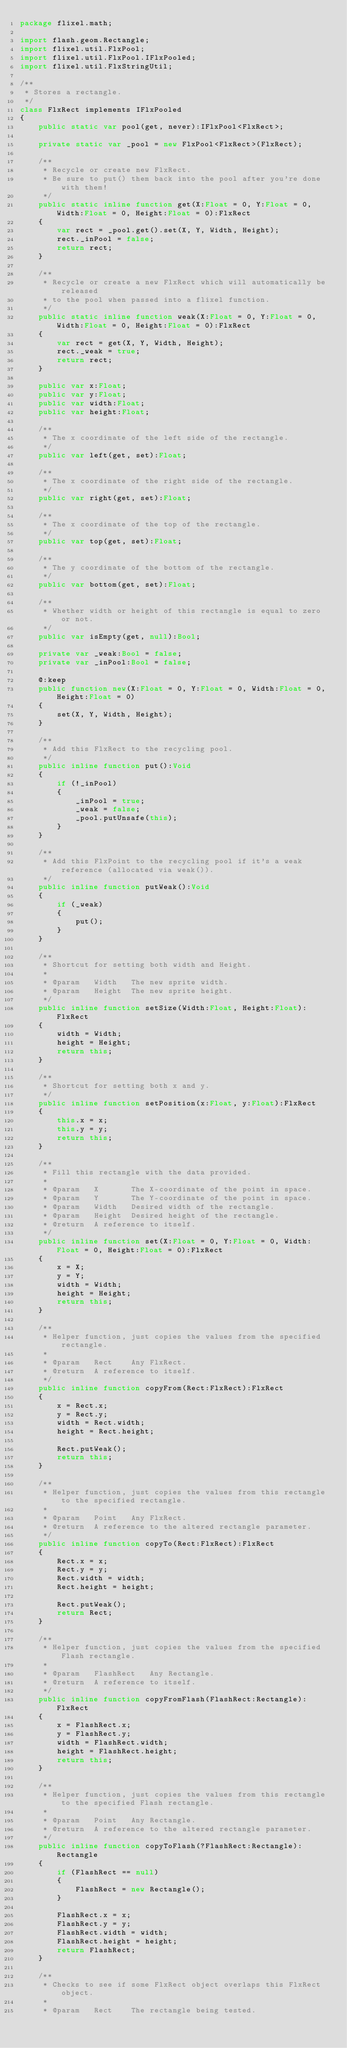<code> <loc_0><loc_0><loc_500><loc_500><_Haxe_>package flixel.math;

import flash.geom.Rectangle;
import flixel.util.FlxPool;
import flixel.util.FlxPool.IFlxPooled;
import flixel.util.FlxStringUtil;

/**
 * Stores a rectangle.
 */
class FlxRect implements IFlxPooled
{
	public static var pool(get, never):IFlxPool<FlxRect>;
	
	private static var _pool = new FlxPool<FlxRect>(FlxRect);
	
	/**
	 * Recycle or create new FlxRect.
	 * Be sure to put() them back into the pool after you're done with them!
	 */
	public static inline function get(X:Float = 0, Y:Float = 0, Width:Float = 0, Height:Float = 0):FlxRect
	{
		var rect = _pool.get().set(X, Y, Width, Height);
		rect._inPool = false;
		return rect;
	}
	
	/**
	 * Recycle or create a new FlxRect which will automatically be released 
	 * to the pool when passed into a flixel function.
	 */
	public static inline function weak(X:Float = 0, Y:Float = 0, Width:Float = 0, Height:Float = 0):FlxRect
	{
		var rect = get(X, Y, Width, Height);
		rect._weak = true;
		return rect;
	}
	
	public var x:Float;
	public var y:Float;
	public var width:Float;
	public var height:Float;
	
	/**
	 * The x coordinate of the left side of the rectangle.
	 */
	public var left(get, set):Float;
	
	/**
	 * The x coordinate of the right side of the rectangle.
	 */
	public var right(get, set):Float;
	
	/**
	 * The x coordinate of the top of the rectangle.
	 */
	public var top(get, set):Float;
	
	/**
	 * The y coordinate of the bottom of the rectangle.
	 */
	public var bottom(get, set):Float;
	
	/**
	 * Whether width or height of this rectangle is equal to zero or not.
	 */
	public var isEmpty(get, null):Bool;
	
	private var _weak:Bool = false;
	private var _inPool:Bool = false;
	
	@:keep
	public function new(X:Float = 0, Y:Float = 0, Width:Float = 0, Height:Float = 0)
	{
		set(X, Y, Width, Height);
	}
	
	/**
	 * Add this FlxRect to the recycling pool.
	 */
	public inline function put():Void
	{
		if (!_inPool)
		{
			_inPool = true;
			_weak = false;
			_pool.putUnsafe(this);
		}
	}
	
	/**
	 * Add this FlxPoint to the recycling pool if it's a weak reference (allocated via weak()).
	 */
	public inline function putWeak():Void
	{
		if (_weak)
		{
			put();
		}
	}
	
	/**
	 * Shortcut for setting both width and Height.
	 * 
	 * @param	Width	The new sprite width.
	 * @param	Height	The new sprite height.
	 */
	public inline function setSize(Width:Float, Height:Float):FlxRect
	{
		width = Width;
		height = Height;
		return this;
	}
	
	/**
	 * Shortcut for setting both x and y.
	 */
	public inline function setPosition(x:Float, y:Float):FlxRect
	{
		this.x = x;
		this.y = y;
		return this;
	}
	
	/**
	 * Fill this rectangle with the data provided.
	 * 
	 * @param	X		The X-coordinate of the point in space.
	 * @param	Y		The Y-coordinate of the point in space.
	 * @param	Width	Desired width of the rectangle.
	 * @param	Height	Desired height of the rectangle.
	 * @return	A reference to itself.
	 */
	public inline function set(X:Float = 0, Y:Float = 0, Width:Float = 0, Height:Float = 0):FlxRect
	{
		x = X;
		y = Y;
		width = Width;
		height = Height;
		return this;
	}

	/**
	 * Helper function, just copies the values from the specified rectangle.
	 * 
	 * @param	Rect	Any FlxRect.
	 * @return	A reference to itself.
	 */
	public inline function copyFrom(Rect:FlxRect):FlxRect
	{
		x = Rect.x;
		y = Rect.y;
		width = Rect.width;
		height = Rect.height;
		
		Rect.putWeak();
		return this;
	}
	
	/**
	 * Helper function, just copies the values from this rectangle to the specified rectangle.
	 * 
	 * @param	Point	Any FlxRect.
	 * @return	A reference to the altered rectangle parameter.
	 */
	public inline function copyTo(Rect:FlxRect):FlxRect
	{
		Rect.x = x;
		Rect.y = y;
		Rect.width = width;
		Rect.height = height;
		
		Rect.putWeak();
		return Rect;
	}
	
	/**
	 * Helper function, just copies the values from the specified Flash rectangle.
	 * 
	 * @param	FlashRect	Any Rectangle.
	 * @return	A reference to itself.
	 */
	public inline function copyFromFlash(FlashRect:Rectangle):FlxRect
	{
		x = FlashRect.x;
		y = FlashRect.y;
		width = FlashRect.width;
		height = FlashRect.height;
		return this;
	}
	
	/**
	 * Helper function, just copies the values from this rectangle to the specified Flash rectangle.
	 * 
	 * @param	Point	Any Rectangle.
	 * @return	A reference to the altered rectangle parameter.
	 */
	public inline function copyToFlash(?FlashRect:Rectangle):Rectangle
	{
		if (FlashRect == null)
		{
			FlashRect = new Rectangle();
		}
		
		FlashRect.x = x;
		FlashRect.y = y;
		FlashRect.width = width;
		FlashRect.height = height;
		return FlashRect;
	}
	
	/**
	 * Checks to see if some FlxRect object overlaps this FlxRect object.
	 * 
	 * @param	Rect	The rectangle being tested.</code> 